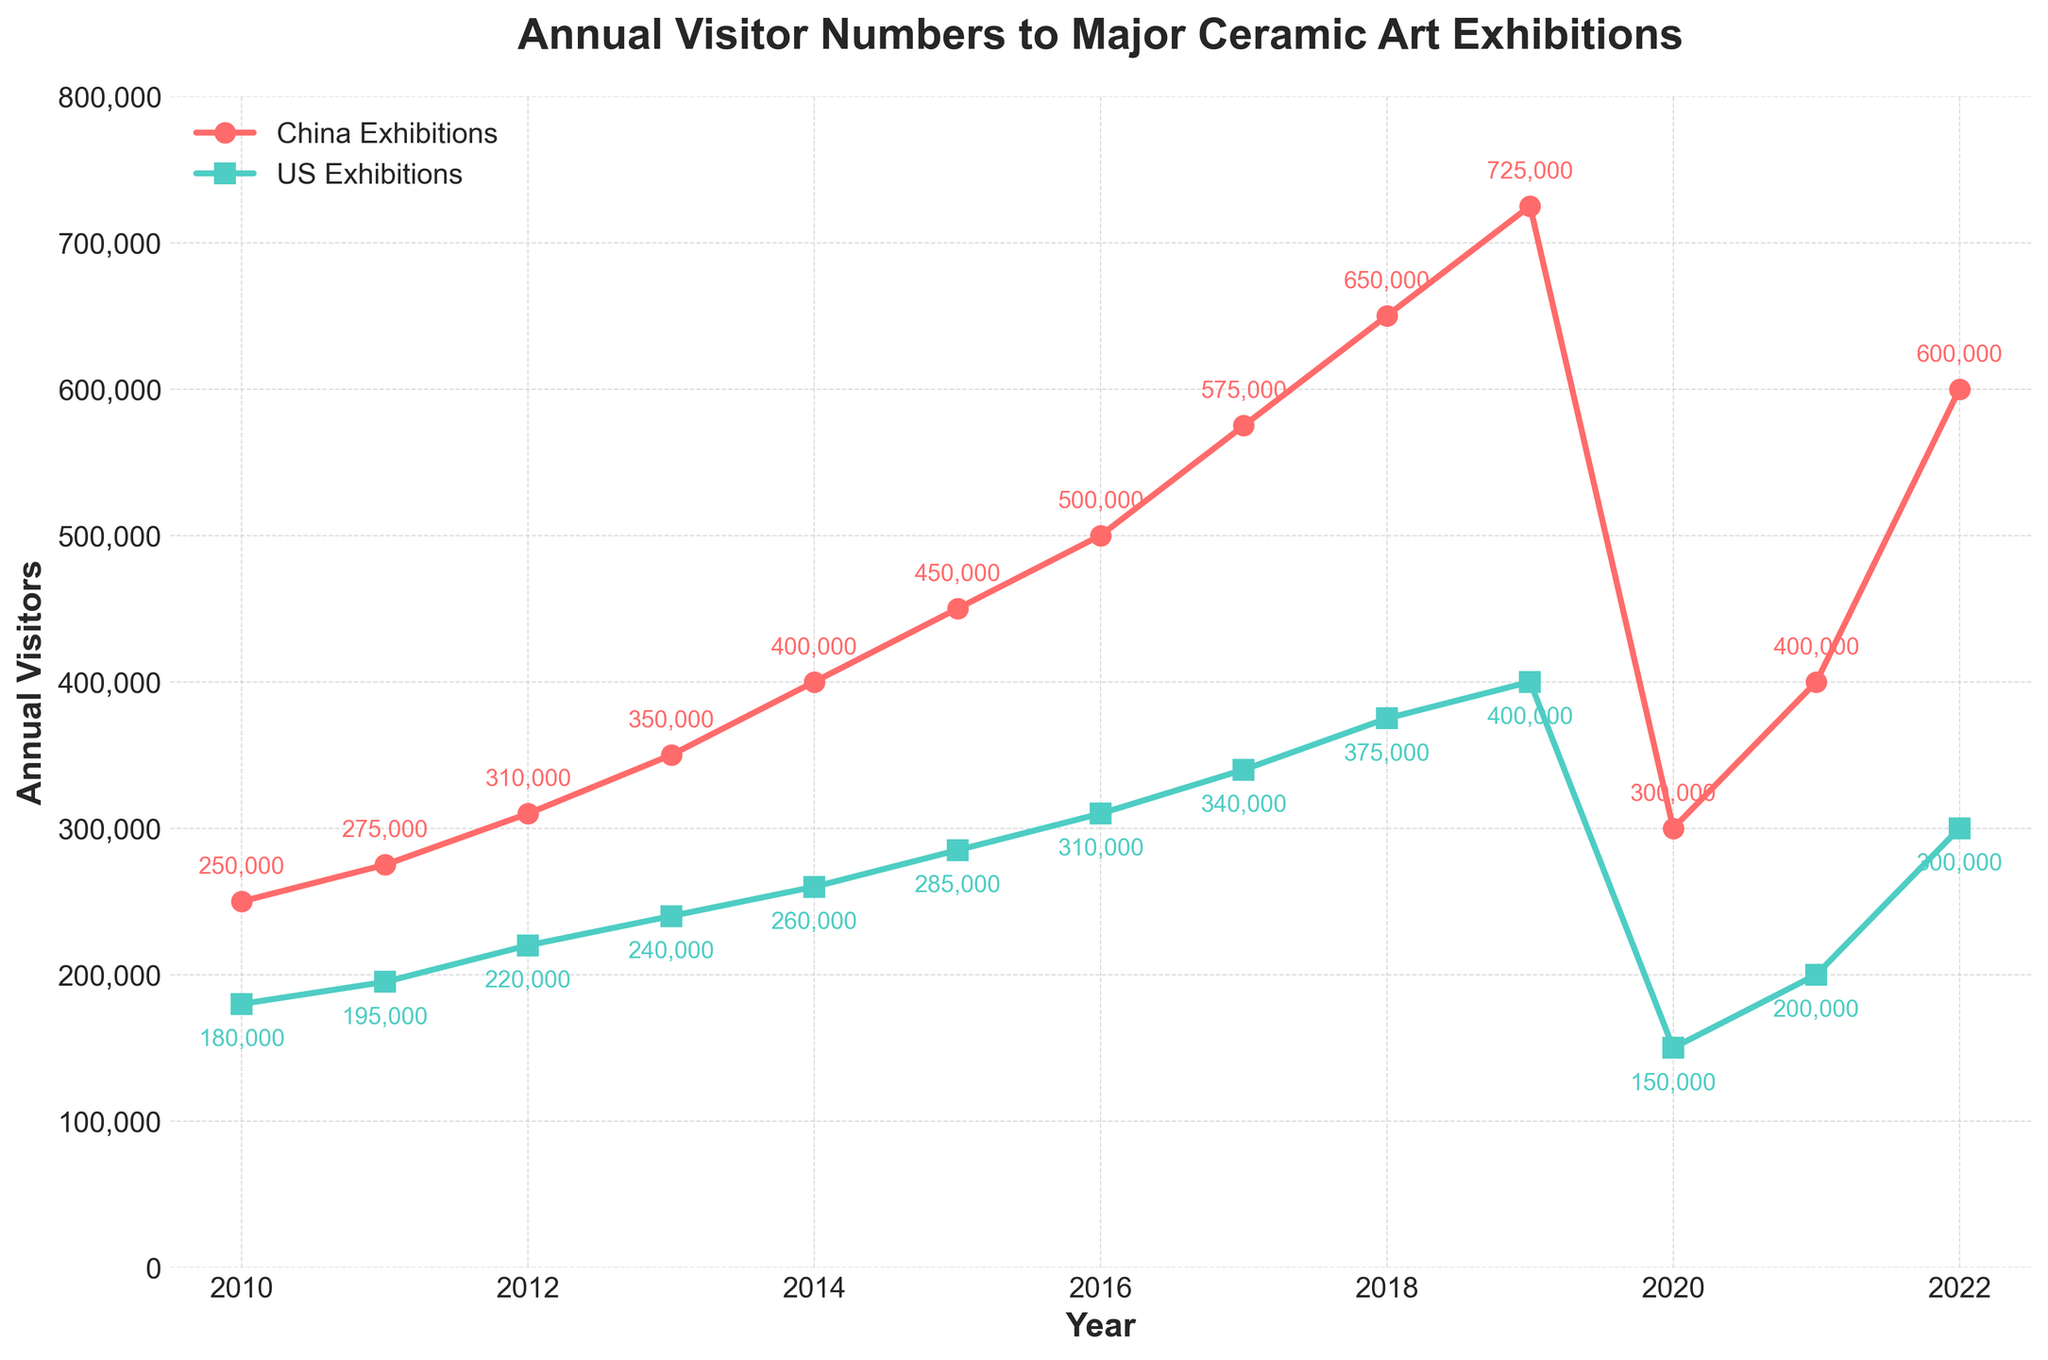What is the difference in annual visitors to ceramic exhibitions between China and the US in 2015? To find the difference, subtract the number of US visitors from the number of China visitors in 2015. From the chart, it's 450,000 (China) - 285,000 (US) = 165,000.
Answer: 165,000 During which year was the gap between China and US exhibition visitors the largest, and what was the gap? By visually inspecting the plot, the gap seems to be the largest in 2019. Checking the annotated values, China had 725,000 visitors and the US had 400,000 visitors. The gap is 725,000 - 400,000 = 325,000.
Answer: 2019, 325,000 What is the combined total of visitors to ceramic exhibitions in China and the US in 2012? Add the number of visitors in China and the US for the year 2012. It is 310,000 (China) + 220,000 (US) = 530,000.
Answer: 530,000 Which year saw the sharpest decline in visitors to ceramic exhibitions in China, and by how much? The sharpest decline can be visually identified between 2019 and 2020 in China. The number dropped from 725,000 in 2019 to 300,000 in 2020. The decline is 725,000 - 300,000 = 425,000.
Answer: 2020, 425,000 What are the highest and lowest visitor numbers for the US ceramic exhibitions across the years? By looking at the plot, the lowest number of US visitors was in 2020, with 150,000 visitors, and the highest was in 2019, with 400,000 visitors.
Answer: Highest: 400,000, Lowest: 150,000 Which year had approximately equal annual visitors for both China and US exhibitions? By visually inspecting the plot, it can be seen that in 2021, both China and the US had nearly equal annual visitors, around 400,000 for China and 200,000 for the US.
Answer: 2021 In which year did China see its visitor numbers double from a previous year, and what were the numbers? Visually identifying the doubling, from 2019 to 2022, China’s visitors went from approximately 300,000 to 600,000, effectively doubling.
Answer: 2022; 300,000 to 600,000 What is the average number of visitors to US exhibitions from 2010 to 2015? Calculate the sum of visitors from 2010 to 2015 and divide it by the number of years (6). The sum is 180,000 + 195,000 + 220,000 + 240,000 + 260,000 + 285,000 = 1,380,000, so the average is 1,380,000 / 6 = 230,000.
Answer: 230,000 